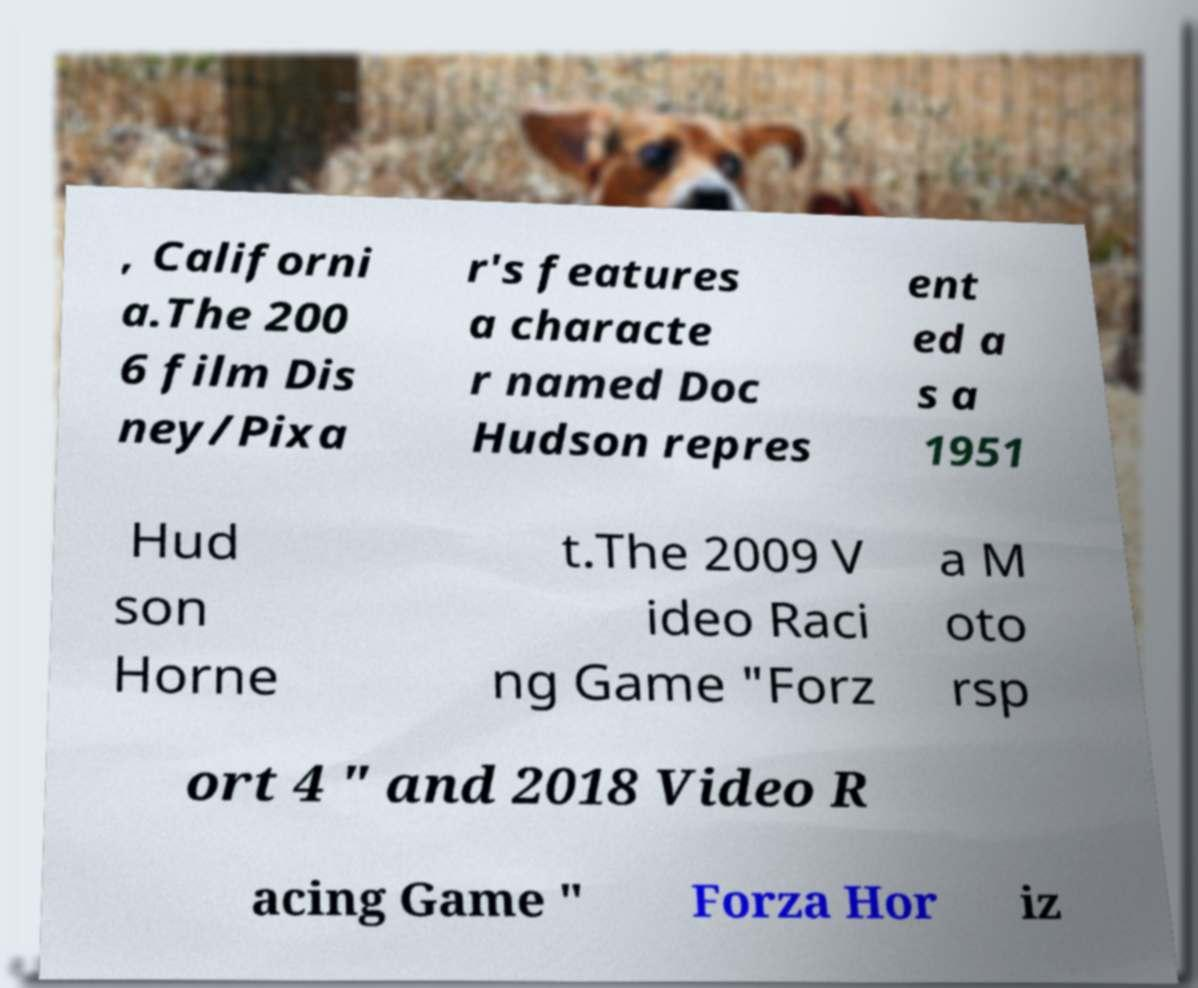Could you assist in decoding the text presented in this image and type it out clearly? , Californi a.The 200 6 film Dis ney/Pixa r's features a characte r named Doc Hudson repres ent ed a s a 1951 Hud son Horne t.The 2009 V ideo Raci ng Game "Forz a M oto rsp ort 4 " and 2018 Video R acing Game " Forza Hor iz 